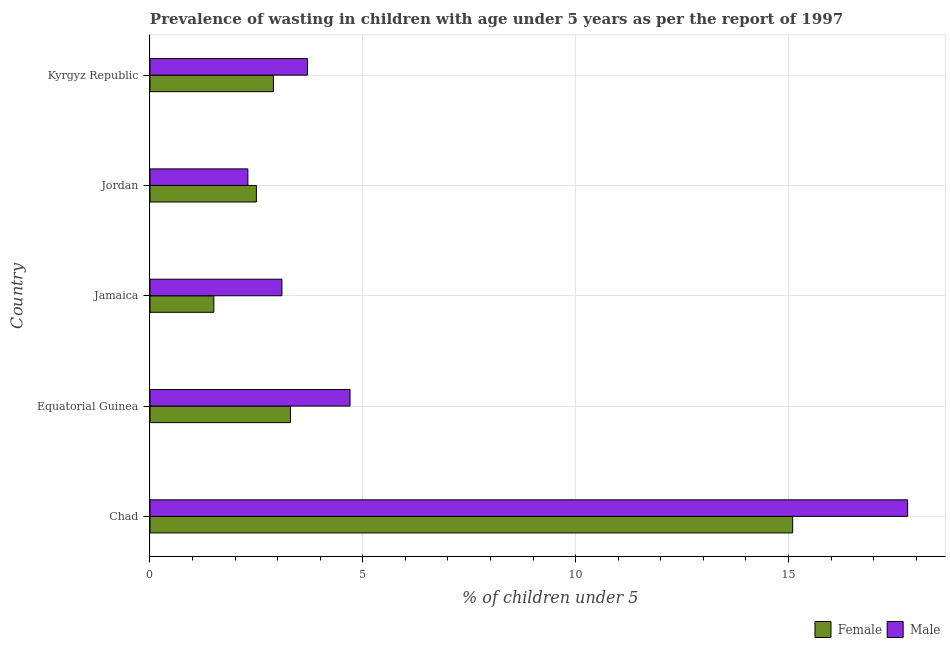How many different coloured bars are there?
Provide a short and direct response. 2. How many groups of bars are there?
Offer a very short reply. 5. What is the label of the 5th group of bars from the top?
Your answer should be very brief. Chad. In how many cases, is the number of bars for a given country not equal to the number of legend labels?
Keep it short and to the point. 0. What is the percentage of undernourished male children in Chad?
Offer a terse response. 17.8. Across all countries, what is the maximum percentage of undernourished male children?
Provide a succinct answer. 17.8. In which country was the percentage of undernourished female children maximum?
Your answer should be compact. Chad. In which country was the percentage of undernourished female children minimum?
Offer a very short reply. Jamaica. What is the total percentage of undernourished female children in the graph?
Offer a terse response. 25.3. What is the difference between the percentage of undernourished male children in Equatorial Guinea and that in Jamaica?
Keep it short and to the point. 1.6. What is the difference between the percentage of undernourished female children in Kyrgyz Republic and the percentage of undernourished male children in Jamaica?
Your answer should be compact. -0.2. What is the average percentage of undernourished female children per country?
Provide a short and direct response. 5.06. What is the difference between the percentage of undernourished male children and percentage of undernourished female children in Equatorial Guinea?
Offer a very short reply. 1.4. In how many countries, is the percentage of undernourished female children greater than 8 %?
Keep it short and to the point. 1. What is the ratio of the percentage of undernourished male children in Jamaica to that in Jordan?
Make the answer very short. 1.35. Is the percentage of undernourished male children in Equatorial Guinea less than that in Kyrgyz Republic?
Offer a very short reply. No. Is the difference between the percentage of undernourished female children in Jamaica and Jordan greater than the difference between the percentage of undernourished male children in Jamaica and Jordan?
Provide a short and direct response. No. Is the sum of the percentage of undernourished female children in Chad and Kyrgyz Republic greater than the maximum percentage of undernourished male children across all countries?
Ensure brevity in your answer.  Yes. What does the 2nd bar from the top in Jamaica represents?
Offer a terse response. Female. What does the 2nd bar from the bottom in Jamaica represents?
Keep it short and to the point. Male. Are all the bars in the graph horizontal?
Your answer should be very brief. Yes. How many countries are there in the graph?
Your answer should be compact. 5. What is the difference between two consecutive major ticks on the X-axis?
Offer a very short reply. 5. Are the values on the major ticks of X-axis written in scientific E-notation?
Provide a succinct answer. No. Does the graph contain any zero values?
Ensure brevity in your answer.  No. How are the legend labels stacked?
Provide a succinct answer. Horizontal. What is the title of the graph?
Offer a very short reply. Prevalence of wasting in children with age under 5 years as per the report of 1997. Does "Male population" appear as one of the legend labels in the graph?
Your response must be concise. No. What is the label or title of the X-axis?
Your response must be concise.  % of children under 5. What is the  % of children under 5 in Female in Chad?
Offer a very short reply. 15.1. What is the  % of children under 5 in Male in Chad?
Provide a short and direct response. 17.8. What is the  % of children under 5 in Female in Equatorial Guinea?
Provide a short and direct response. 3.3. What is the  % of children under 5 in Male in Equatorial Guinea?
Offer a very short reply. 4.7. What is the  % of children under 5 in Male in Jamaica?
Offer a terse response. 3.1. What is the  % of children under 5 in Female in Jordan?
Ensure brevity in your answer.  2.5. What is the  % of children under 5 of Male in Jordan?
Your answer should be compact. 2.3. What is the  % of children under 5 in Female in Kyrgyz Republic?
Give a very brief answer. 2.9. What is the  % of children under 5 of Male in Kyrgyz Republic?
Your answer should be compact. 3.7. Across all countries, what is the maximum  % of children under 5 in Female?
Give a very brief answer. 15.1. Across all countries, what is the maximum  % of children under 5 of Male?
Ensure brevity in your answer.  17.8. Across all countries, what is the minimum  % of children under 5 in Female?
Offer a very short reply. 1.5. Across all countries, what is the minimum  % of children under 5 of Male?
Keep it short and to the point. 2.3. What is the total  % of children under 5 in Female in the graph?
Provide a short and direct response. 25.3. What is the total  % of children under 5 of Male in the graph?
Provide a succinct answer. 31.6. What is the difference between the  % of children under 5 in Female in Chad and that in Equatorial Guinea?
Provide a succinct answer. 11.8. What is the difference between the  % of children under 5 of Male in Chad and that in Equatorial Guinea?
Offer a terse response. 13.1. What is the difference between the  % of children under 5 in Female in Chad and that in Jordan?
Ensure brevity in your answer.  12.6. What is the difference between the  % of children under 5 in Male in Chad and that in Jordan?
Your answer should be compact. 15.5. What is the difference between the  % of children under 5 of Female in Chad and that in Kyrgyz Republic?
Offer a terse response. 12.2. What is the difference between the  % of children under 5 of Female in Equatorial Guinea and that in Jamaica?
Keep it short and to the point. 1.8. What is the difference between the  % of children under 5 of Male in Equatorial Guinea and that in Jamaica?
Keep it short and to the point. 1.6. What is the difference between the  % of children under 5 in Female in Equatorial Guinea and that in Jordan?
Your answer should be very brief. 0.8. What is the difference between the  % of children under 5 in Male in Equatorial Guinea and that in Jordan?
Offer a very short reply. 2.4. What is the difference between the  % of children under 5 of Female in Equatorial Guinea and that in Kyrgyz Republic?
Provide a short and direct response. 0.4. What is the difference between the  % of children under 5 of Male in Equatorial Guinea and that in Kyrgyz Republic?
Make the answer very short. 1. What is the difference between the  % of children under 5 of Female in Jamaica and that in Jordan?
Your answer should be compact. -1. What is the difference between the  % of children under 5 in Male in Jamaica and that in Jordan?
Provide a short and direct response. 0.8. What is the difference between the  % of children under 5 of Female in Jamaica and that in Kyrgyz Republic?
Your answer should be very brief. -1.4. What is the difference between the  % of children under 5 in Female in Chad and the  % of children under 5 in Male in Equatorial Guinea?
Ensure brevity in your answer.  10.4. What is the difference between the  % of children under 5 in Female in Chad and the  % of children under 5 in Male in Jordan?
Provide a succinct answer. 12.8. What is the difference between the  % of children under 5 of Female in Equatorial Guinea and the  % of children under 5 of Male in Jamaica?
Offer a terse response. 0.2. What is the difference between the  % of children under 5 in Female in Equatorial Guinea and the  % of children under 5 in Male in Kyrgyz Republic?
Ensure brevity in your answer.  -0.4. What is the difference between the  % of children under 5 of Female in Jamaica and the  % of children under 5 of Male in Kyrgyz Republic?
Your answer should be very brief. -2.2. What is the difference between the  % of children under 5 in Female in Jordan and the  % of children under 5 in Male in Kyrgyz Republic?
Keep it short and to the point. -1.2. What is the average  % of children under 5 in Female per country?
Offer a very short reply. 5.06. What is the average  % of children under 5 in Male per country?
Offer a very short reply. 6.32. What is the difference between the  % of children under 5 of Female and  % of children under 5 of Male in Chad?
Keep it short and to the point. -2.7. What is the difference between the  % of children under 5 of Female and  % of children under 5 of Male in Equatorial Guinea?
Provide a succinct answer. -1.4. What is the difference between the  % of children under 5 in Female and  % of children under 5 in Male in Kyrgyz Republic?
Provide a succinct answer. -0.8. What is the ratio of the  % of children under 5 in Female in Chad to that in Equatorial Guinea?
Keep it short and to the point. 4.58. What is the ratio of the  % of children under 5 in Male in Chad to that in Equatorial Guinea?
Give a very brief answer. 3.79. What is the ratio of the  % of children under 5 in Female in Chad to that in Jamaica?
Ensure brevity in your answer.  10.07. What is the ratio of the  % of children under 5 in Male in Chad to that in Jamaica?
Keep it short and to the point. 5.74. What is the ratio of the  % of children under 5 in Female in Chad to that in Jordan?
Ensure brevity in your answer.  6.04. What is the ratio of the  % of children under 5 of Male in Chad to that in Jordan?
Ensure brevity in your answer.  7.74. What is the ratio of the  % of children under 5 in Female in Chad to that in Kyrgyz Republic?
Offer a terse response. 5.21. What is the ratio of the  % of children under 5 of Male in Chad to that in Kyrgyz Republic?
Ensure brevity in your answer.  4.81. What is the ratio of the  % of children under 5 of Male in Equatorial Guinea to that in Jamaica?
Offer a terse response. 1.52. What is the ratio of the  % of children under 5 in Female in Equatorial Guinea to that in Jordan?
Your answer should be compact. 1.32. What is the ratio of the  % of children under 5 of Male in Equatorial Guinea to that in Jordan?
Make the answer very short. 2.04. What is the ratio of the  % of children under 5 of Female in Equatorial Guinea to that in Kyrgyz Republic?
Your answer should be compact. 1.14. What is the ratio of the  % of children under 5 of Male in Equatorial Guinea to that in Kyrgyz Republic?
Your answer should be compact. 1.27. What is the ratio of the  % of children under 5 in Female in Jamaica to that in Jordan?
Make the answer very short. 0.6. What is the ratio of the  % of children under 5 of Male in Jamaica to that in Jordan?
Ensure brevity in your answer.  1.35. What is the ratio of the  % of children under 5 in Female in Jamaica to that in Kyrgyz Republic?
Your answer should be very brief. 0.52. What is the ratio of the  % of children under 5 of Male in Jamaica to that in Kyrgyz Republic?
Your answer should be compact. 0.84. What is the ratio of the  % of children under 5 of Female in Jordan to that in Kyrgyz Republic?
Offer a very short reply. 0.86. What is the ratio of the  % of children under 5 of Male in Jordan to that in Kyrgyz Republic?
Ensure brevity in your answer.  0.62. What is the difference between the highest and the second highest  % of children under 5 of Female?
Keep it short and to the point. 11.8. What is the difference between the highest and the second highest  % of children under 5 in Male?
Offer a terse response. 13.1. What is the difference between the highest and the lowest  % of children under 5 in Male?
Provide a succinct answer. 15.5. 